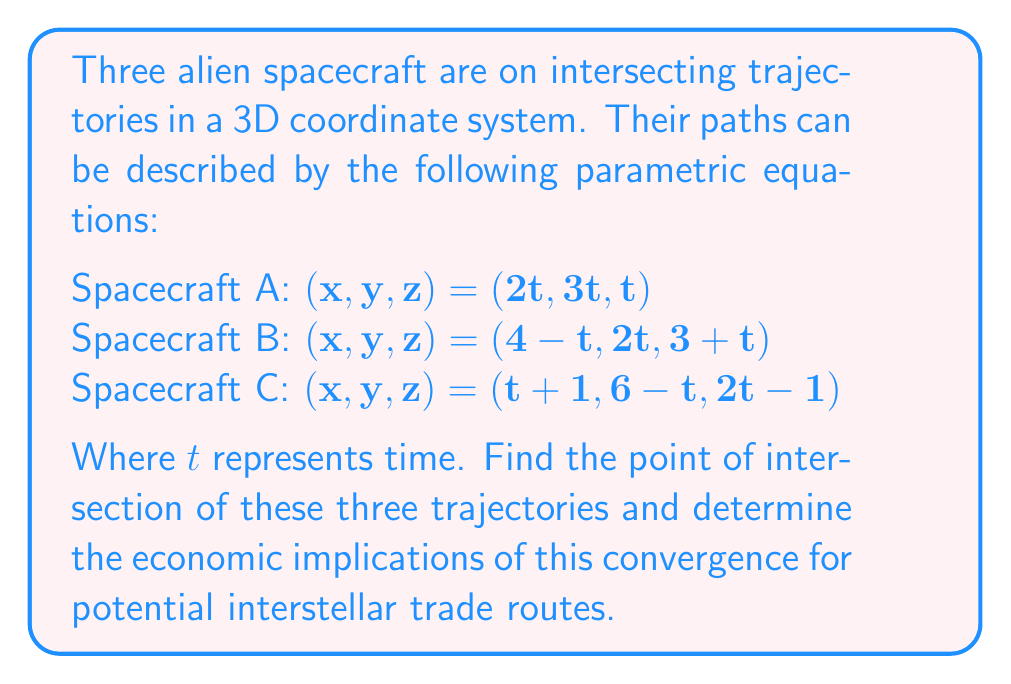What is the answer to this math problem? To find the intersection point, we need to equate the x, y, and z components of each spacecraft's equations:

1) Equate x-coordinates:
   $$2t = 4 - t = t + 1$$
   
   From $2t = t + 1$, we get $t = 1$
   Verify: $2(1) = 4 - 1 = 1 + 1 = 2$

2) Equate y-coordinates:
   $$3t = 2t = 6 - t$$
   
   Substituting $t = 1$:
   $$3(1) = 2(1) = 6 - 1$$
   $$3 = 2 = 5$$ (This is true for $t = 1$)

3) Equate z-coordinates:
   $$t = 3 + t = 2t - 1$$
   
   Substituting $t = 1$:
   $$1 = 3 + 1 = 2(1) - 1$$
   $$1 = 4 = 1$$ (This is true for $t = 1$)

Therefore, the intersection point occurs at $t = 1$ for all spacecraft.

To find the coordinates of the intersection point:

Spacecraft A: $(2(1), 3(1), 1) = (2, 3, 1)$
Spacecraft B: $(4 - 1, 2(1), 3 + 1) = (3, 2, 4)$
Spacecraft C: $(1 + 1, 6 - 1, 2(1) - 1) = (2, 5, 1)$

The intersection point is $(2, 3, 1)$.

Economic Implications:
1. This convergence point could serve as a strategic location for an interstellar trading hub or space station.
2. The intersection of multiple spacecraft routes suggests this could be a high-traffic area, potentially leading to economic opportunities in refueling, maintenance, and trade services.
3. The coordinates of the intersection point (2, 3, 1) might indicate proximity to valuable resources or strategic positioning in the galaxy, which could influence the economic value of this location.
4. The timing of the intersection (t = 1) could be used to synchronize trade schedules and optimize resource allocation in interstellar commerce.
Answer: The three spacecraft intersect at the point $(2, 3, 1)$ when $t = 1$. This point represents a potential strategic location for interstellar trade and economic development. 